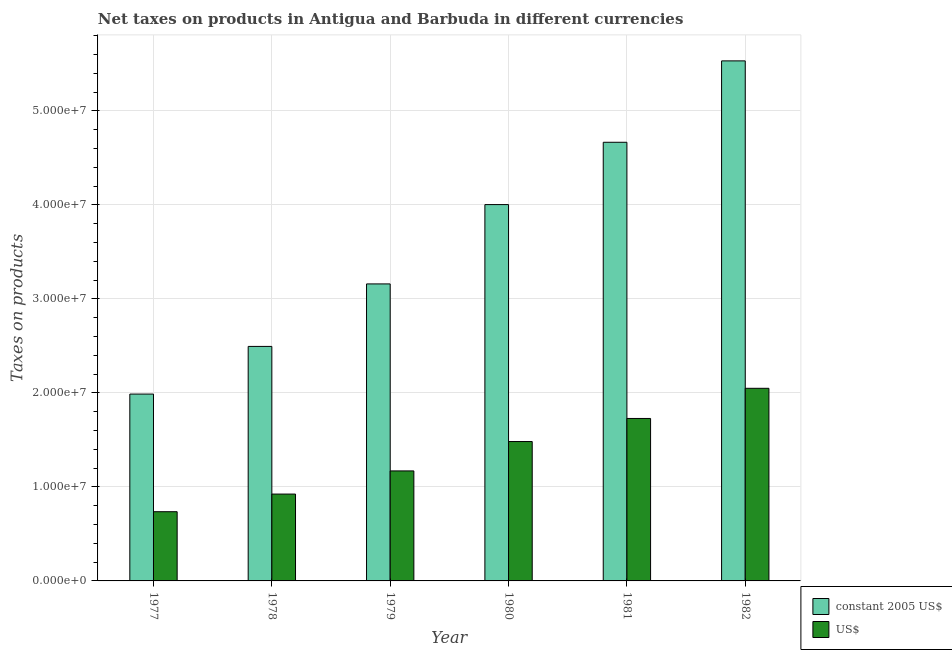How many groups of bars are there?
Give a very brief answer. 6. How many bars are there on the 3rd tick from the right?
Ensure brevity in your answer.  2. What is the label of the 6th group of bars from the left?
Your response must be concise. 1982. In how many cases, is the number of bars for a given year not equal to the number of legend labels?
Make the answer very short. 0. What is the net taxes in constant 2005 us$ in 1979?
Make the answer very short. 3.16e+07. Across all years, what is the maximum net taxes in constant 2005 us$?
Provide a short and direct response. 5.53e+07. Across all years, what is the minimum net taxes in us$?
Give a very brief answer. 7.36e+06. In which year was the net taxes in constant 2005 us$ maximum?
Your answer should be very brief. 1982. What is the total net taxes in us$ in the graph?
Provide a succinct answer. 8.09e+07. What is the difference between the net taxes in constant 2005 us$ in 1978 and that in 1979?
Make the answer very short. -6.65e+06. What is the difference between the net taxes in us$ in 1981 and the net taxes in constant 2005 us$ in 1982?
Provide a succinct answer. -3.21e+06. What is the average net taxes in us$ per year?
Your response must be concise. 1.35e+07. In the year 1980, what is the difference between the net taxes in us$ and net taxes in constant 2005 us$?
Ensure brevity in your answer.  0. In how many years, is the net taxes in us$ greater than 40000000 units?
Give a very brief answer. 0. What is the ratio of the net taxes in constant 2005 us$ in 1977 to that in 1980?
Make the answer very short. 0.5. What is the difference between the highest and the second highest net taxes in constant 2005 us$?
Offer a terse response. 8.66e+06. What is the difference between the highest and the lowest net taxes in constant 2005 us$?
Your answer should be compact. 3.54e+07. Is the sum of the net taxes in constant 2005 us$ in 1978 and 1979 greater than the maximum net taxes in us$ across all years?
Give a very brief answer. Yes. What does the 1st bar from the left in 1982 represents?
Ensure brevity in your answer.  Constant 2005 us$. What does the 2nd bar from the right in 1979 represents?
Your answer should be very brief. Constant 2005 us$. Are all the bars in the graph horizontal?
Keep it short and to the point. No. What is the difference between two consecutive major ticks on the Y-axis?
Keep it short and to the point. 1.00e+07. Are the values on the major ticks of Y-axis written in scientific E-notation?
Ensure brevity in your answer.  Yes. Does the graph contain any zero values?
Give a very brief answer. No. How are the legend labels stacked?
Provide a short and direct response. Vertical. What is the title of the graph?
Your answer should be very brief. Net taxes on products in Antigua and Barbuda in different currencies. What is the label or title of the Y-axis?
Keep it short and to the point. Taxes on products. What is the Taxes on products in constant 2005 US$ in 1977?
Make the answer very short. 1.99e+07. What is the Taxes on products in US$ in 1977?
Provide a short and direct response. 7.36e+06. What is the Taxes on products of constant 2005 US$ in 1978?
Offer a terse response. 2.50e+07. What is the Taxes on products of US$ in 1978?
Your response must be concise. 9.24e+06. What is the Taxes on products in constant 2005 US$ in 1979?
Provide a short and direct response. 3.16e+07. What is the Taxes on products of US$ in 1979?
Make the answer very short. 1.17e+07. What is the Taxes on products of constant 2005 US$ in 1980?
Provide a succinct answer. 4.00e+07. What is the Taxes on products in US$ in 1980?
Your response must be concise. 1.48e+07. What is the Taxes on products in constant 2005 US$ in 1981?
Make the answer very short. 4.67e+07. What is the Taxes on products in US$ in 1981?
Ensure brevity in your answer.  1.73e+07. What is the Taxes on products in constant 2005 US$ in 1982?
Ensure brevity in your answer.  5.53e+07. What is the Taxes on products of US$ in 1982?
Your answer should be compact. 2.05e+07. Across all years, what is the maximum Taxes on products of constant 2005 US$?
Your response must be concise. 5.53e+07. Across all years, what is the maximum Taxes on products in US$?
Keep it short and to the point. 2.05e+07. Across all years, what is the minimum Taxes on products of constant 2005 US$?
Keep it short and to the point. 1.99e+07. Across all years, what is the minimum Taxes on products in US$?
Your answer should be very brief. 7.36e+06. What is the total Taxes on products in constant 2005 US$ in the graph?
Your answer should be very brief. 2.18e+08. What is the total Taxes on products of US$ in the graph?
Your answer should be compact. 8.09e+07. What is the difference between the Taxes on products in constant 2005 US$ in 1977 and that in 1978?
Provide a short and direct response. -5.07e+06. What is the difference between the Taxes on products of US$ in 1977 and that in 1978?
Offer a terse response. -1.88e+06. What is the difference between the Taxes on products in constant 2005 US$ in 1977 and that in 1979?
Offer a terse response. -1.17e+07. What is the difference between the Taxes on products in US$ in 1977 and that in 1979?
Your answer should be compact. -4.34e+06. What is the difference between the Taxes on products of constant 2005 US$ in 1977 and that in 1980?
Give a very brief answer. -2.02e+07. What is the difference between the Taxes on products in US$ in 1977 and that in 1980?
Your response must be concise. -7.47e+06. What is the difference between the Taxes on products of constant 2005 US$ in 1977 and that in 1981?
Provide a short and direct response. -2.68e+07. What is the difference between the Taxes on products in US$ in 1977 and that in 1981?
Your response must be concise. -9.92e+06. What is the difference between the Taxes on products in constant 2005 US$ in 1977 and that in 1982?
Ensure brevity in your answer.  -3.54e+07. What is the difference between the Taxes on products of US$ in 1977 and that in 1982?
Provide a succinct answer. -1.31e+07. What is the difference between the Taxes on products in constant 2005 US$ in 1978 and that in 1979?
Provide a succinct answer. -6.65e+06. What is the difference between the Taxes on products in US$ in 1978 and that in 1979?
Offer a terse response. -2.46e+06. What is the difference between the Taxes on products of constant 2005 US$ in 1978 and that in 1980?
Give a very brief answer. -1.51e+07. What is the difference between the Taxes on products in US$ in 1978 and that in 1980?
Provide a succinct answer. -5.59e+06. What is the difference between the Taxes on products in constant 2005 US$ in 1978 and that in 1981?
Your answer should be compact. -2.17e+07. What is the difference between the Taxes on products of US$ in 1978 and that in 1981?
Offer a very short reply. -8.04e+06. What is the difference between the Taxes on products in constant 2005 US$ in 1978 and that in 1982?
Offer a very short reply. -3.04e+07. What is the difference between the Taxes on products of US$ in 1978 and that in 1982?
Ensure brevity in your answer.  -1.13e+07. What is the difference between the Taxes on products of constant 2005 US$ in 1979 and that in 1980?
Give a very brief answer. -8.44e+06. What is the difference between the Taxes on products in US$ in 1979 and that in 1980?
Give a very brief answer. -3.13e+06. What is the difference between the Taxes on products of constant 2005 US$ in 1979 and that in 1981?
Your response must be concise. -1.51e+07. What is the difference between the Taxes on products in US$ in 1979 and that in 1981?
Provide a succinct answer. -5.58e+06. What is the difference between the Taxes on products in constant 2005 US$ in 1979 and that in 1982?
Keep it short and to the point. -2.37e+07. What is the difference between the Taxes on products of US$ in 1979 and that in 1982?
Provide a succinct answer. -8.79e+06. What is the difference between the Taxes on products of constant 2005 US$ in 1980 and that in 1981?
Your answer should be very brief. -6.63e+06. What is the difference between the Taxes on products of US$ in 1980 and that in 1981?
Keep it short and to the point. -2.46e+06. What is the difference between the Taxes on products in constant 2005 US$ in 1980 and that in 1982?
Ensure brevity in your answer.  -1.53e+07. What is the difference between the Taxes on products of US$ in 1980 and that in 1982?
Offer a terse response. -5.66e+06. What is the difference between the Taxes on products of constant 2005 US$ in 1981 and that in 1982?
Give a very brief answer. -8.66e+06. What is the difference between the Taxes on products of US$ in 1981 and that in 1982?
Keep it short and to the point. -3.21e+06. What is the difference between the Taxes on products of constant 2005 US$ in 1977 and the Taxes on products of US$ in 1978?
Keep it short and to the point. 1.06e+07. What is the difference between the Taxes on products of constant 2005 US$ in 1977 and the Taxes on products of US$ in 1979?
Your response must be concise. 8.18e+06. What is the difference between the Taxes on products of constant 2005 US$ in 1977 and the Taxes on products of US$ in 1980?
Your answer should be compact. 5.05e+06. What is the difference between the Taxes on products in constant 2005 US$ in 1977 and the Taxes on products in US$ in 1981?
Give a very brief answer. 2.59e+06. What is the difference between the Taxes on products of constant 2005 US$ in 1977 and the Taxes on products of US$ in 1982?
Ensure brevity in your answer.  -6.13e+05. What is the difference between the Taxes on products in constant 2005 US$ in 1978 and the Taxes on products in US$ in 1979?
Give a very brief answer. 1.32e+07. What is the difference between the Taxes on products of constant 2005 US$ in 1978 and the Taxes on products of US$ in 1980?
Offer a terse response. 1.01e+07. What is the difference between the Taxes on products in constant 2005 US$ in 1978 and the Taxes on products in US$ in 1981?
Offer a very short reply. 7.66e+06. What is the difference between the Taxes on products of constant 2005 US$ in 1978 and the Taxes on products of US$ in 1982?
Offer a very short reply. 4.46e+06. What is the difference between the Taxes on products in constant 2005 US$ in 1979 and the Taxes on products in US$ in 1980?
Your answer should be compact. 1.68e+07. What is the difference between the Taxes on products of constant 2005 US$ in 1979 and the Taxes on products of US$ in 1981?
Offer a terse response. 1.43e+07. What is the difference between the Taxes on products in constant 2005 US$ in 1979 and the Taxes on products in US$ in 1982?
Ensure brevity in your answer.  1.11e+07. What is the difference between the Taxes on products in constant 2005 US$ in 1980 and the Taxes on products in US$ in 1981?
Ensure brevity in your answer.  2.28e+07. What is the difference between the Taxes on products in constant 2005 US$ in 1980 and the Taxes on products in US$ in 1982?
Your answer should be very brief. 1.95e+07. What is the difference between the Taxes on products in constant 2005 US$ in 1981 and the Taxes on products in US$ in 1982?
Offer a very short reply. 2.62e+07. What is the average Taxes on products in constant 2005 US$ per year?
Keep it short and to the point. 3.64e+07. What is the average Taxes on products of US$ per year?
Keep it short and to the point. 1.35e+07. In the year 1977, what is the difference between the Taxes on products of constant 2005 US$ and Taxes on products of US$?
Your answer should be compact. 1.25e+07. In the year 1978, what is the difference between the Taxes on products of constant 2005 US$ and Taxes on products of US$?
Your answer should be very brief. 1.57e+07. In the year 1979, what is the difference between the Taxes on products of constant 2005 US$ and Taxes on products of US$?
Ensure brevity in your answer.  1.99e+07. In the year 1980, what is the difference between the Taxes on products in constant 2005 US$ and Taxes on products in US$?
Give a very brief answer. 2.52e+07. In the year 1981, what is the difference between the Taxes on products of constant 2005 US$ and Taxes on products of US$?
Make the answer very short. 2.94e+07. In the year 1982, what is the difference between the Taxes on products in constant 2005 US$ and Taxes on products in US$?
Your answer should be compact. 3.48e+07. What is the ratio of the Taxes on products in constant 2005 US$ in 1977 to that in 1978?
Provide a succinct answer. 0.8. What is the ratio of the Taxes on products of US$ in 1977 to that in 1978?
Ensure brevity in your answer.  0.8. What is the ratio of the Taxes on products in constant 2005 US$ in 1977 to that in 1979?
Your answer should be compact. 0.63. What is the ratio of the Taxes on products in US$ in 1977 to that in 1979?
Ensure brevity in your answer.  0.63. What is the ratio of the Taxes on products of constant 2005 US$ in 1977 to that in 1980?
Your response must be concise. 0.5. What is the ratio of the Taxes on products in US$ in 1977 to that in 1980?
Your answer should be very brief. 0.5. What is the ratio of the Taxes on products of constant 2005 US$ in 1977 to that in 1981?
Offer a very short reply. 0.43. What is the ratio of the Taxes on products in US$ in 1977 to that in 1981?
Offer a terse response. 0.43. What is the ratio of the Taxes on products in constant 2005 US$ in 1977 to that in 1982?
Make the answer very short. 0.36. What is the ratio of the Taxes on products of US$ in 1977 to that in 1982?
Provide a succinct answer. 0.36. What is the ratio of the Taxes on products in constant 2005 US$ in 1978 to that in 1979?
Your answer should be very brief. 0.79. What is the ratio of the Taxes on products in US$ in 1978 to that in 1979?
Ensure brevity in your answer.  0.79. What is the ratio of the Taxes on products of constant 2005 US$ in 1978 to that in 1980?
Provide a short and direct response. 0.62. What is the ratio of the Taxes on products in US$ in 1978 to that in 1980?
Make the answer very short. 0.62. What is the ratio of the Taxes on products in constant 2005 US$ in 1978 to that in 1981?
Keep it short and to the point. 0.53. What is the ratio of the Taxes on products in US$ in 1978 to that in 1981?
Provide a succinct answer. 0.53. What is the ratio of the Taxes on products in constant 2005 US$ in 1978 to that in 1982?
Your response must be concise. 0.45. What is the ratio of the Taxes on products of US$ in 1978 to that in 1982?
Your response must be concise. 0.45. What is the ratio of the Taxes on products of constant 2005 US$ in 1979 to that in 1980?
Offer a terse response. 0.79. What is the ratio of the Taxes on products in US$ in 1979 to that in 1980?
Offer a very short reply. 0.79. What is the ratio of the Taxes on products in constant 2005 US$ in 1979 to that in 1981?
Make the answer very short. 0.68. What is the ratio of the Taxes on products in US$ in 1979 to that in 1981?
Your answer should be compact. 0.68. What is the ratio of the Taxes on products of constant 2005 US$ in 1979 to that in 1982?
Your response must be concise. 0.57. What is the ratio of the Taxes on products in US$ in 1979 to that in 1982?
Your answer should be very brief. 0.57. What is the ratio of the Taxes on products of constant 2005 US$ in 1980 to that in 1981?
Ensure brevity in your answer.  0.86. What is the ratio of the Taxes on products of US$ in 1980 to that in 1981?
Offer a terse response. 0.86. What is the ratio of the Taxes on products in constant 2005 US$ in 1980 to that in 1982?
Your response must be concise. 0.72. What is the ratio of the Taxes on products of US$ in 1980 to that in 1982?
Provide a short and direct response. 0.72. What is the ratio of the Taxes on products of constant 2005 US$ in 1981 to that in 1982?
Your response must be concise. 0.84. What is the ratio of the Taxes on products of US$ in 1981 to that in 1982?
Provide a succinct answer. 0.84. What is the difference between the highest and the second highest Taxes on products in constant 2005 US$?
Give a very brief answer. 8.66e+06. What is the difference between the highest and the second highest Taxes on products of US$?
Provide a short and direct response. 3.21e+06. What is the difference between the highest and the lowest Taxes on products of constant 2005 US$?
Provide a succinct answer. 3.54e+07. What is the difference between the highest and the lowest Taxes on products of US$?
Your answer should be compact. 1.31e+07. 